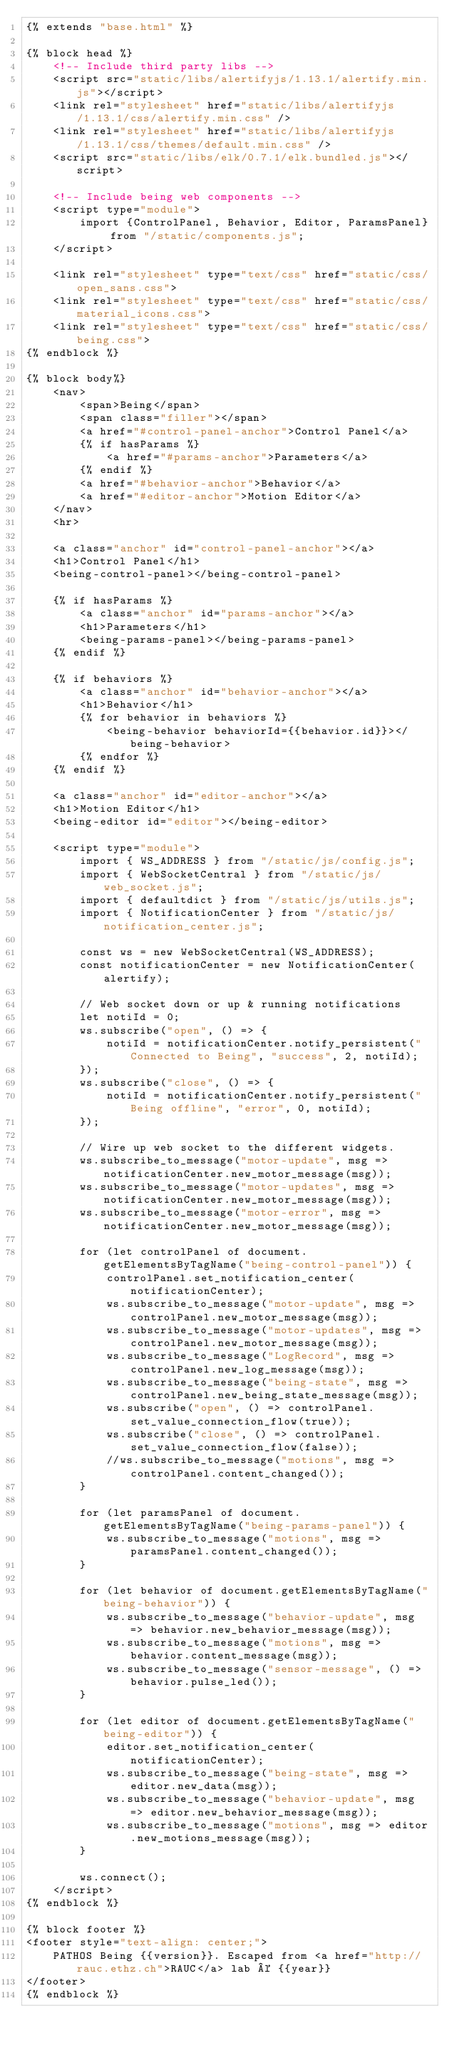Convert code to text. <code><loc_0><loc_0><loc_500><loc_500><_HTML_>{% extends "base.html" %}

{% block head %}
    <!-- Include third party libs -->
    <script src="static/libs/alertifyjs/1.13.1/alertify.min.js"></script>
    <link rel="stylesheet" href="static/libs/alertifyjs/1.13.1/css/alertify.min.css" />
    <link rel="stylesheet" href="static/libs/alertifyjs/1.13.1/css/themes/default.min.css" />
    <script src="static/libs/elk/0.7.1/elk.bundled.js"></script>

    <!-- Include being web components -->
    <script type="module">
        import {ControlPanel, Behavior, Editor, ParamsPanel} from "/static/components.js";
    </script>

    <link rel="stylesheet" type="text/css" href="static/css/open_sans.css">
    <link rel="stylesheet" type="text/css" href="static/css/material_icons.css">
    <link rel="stylesheet" type="text/css" href="static/css/being.css">
{% endblock %}

{% block body%}
    <nav>
        <span>Being</span>
        <span class="filler"></span>
        <a href="#control-panel-anchor">Control Panel</a>
        {% if hasParams %}
            <a href="#params-anchor">Parameters</a>
        {% endif %}
        <a href="#behavior-anchor">Behavior</a>
        <a href="#editor-anchor">Motion Editor</a>
    </nav>
    <hr>

    <a class="anchor" id="control-panel-anchor"></a>
    <h1>Control Panel</h1>
    <being-control-panel></being-control-panel>

    {% if hasParams %}
        <a class="anchor" id="params-anchor"></a>
        <h1>Parameters</h1>
        <being-params-panel></being-params-panel>
    {% endif %}

    {% if behaviors %}
        <a class="anchor" id="behavior-anchor"></a>
        <h1>Behavior</h1>
        {% for behavior in behaviors %}
            <being-behavior behaviorId={{behavior.id}}></being-behavior>
        {% endfor %}
    {% endif %}

    <a class="anchor" id="editor-anchor"></a>
    <h1>Motion Editor</h1>
    <being-editor id="editor"></being-editor>

    <script type="module">
        import { WS_ADDRESS } from "/static/js/config.js";
        import { WebSocketCentral } from "/static/js/web_socket.js";
        import { defaultdict } from "/static/js/utils.js";
        import { NotificationCenter } from "/static/js/notification_center.js";

        const ws = new WebSocketCentral(WS_ADDRESS);
        const notificationCenter = new NotificationCenter(alertify);

        // Web socket down or up & running notifications
        let notiId = 0;
        ws.subscribe("open", () => {
            notiId = notificationCenter.notify_persistent("Connected to Being", "success", 2, notiId);
        });
        ws.subscribe("close", () => {
            notiId = notificationCenter.notify_persistent("Being offline", "error", 0, notiId);
        });

        // Wire up web socket to the different widgets.
        ws.subscribe_to_message("motor-update", msg => notificationCenter.new_motor_message(msg));
        ws.subscribe_to_message("motor-updates", msg => notificationCenter.new_motor_message(msg));
        ws.subscribe_to_message("motor-error", msg => notificationCenter.new_motor_message(msg));

        for (let controlPanel of document.getElementsByTagName("being-control-panel")) {
            controlPanel.set_notification_center(notificationCenter);
            ws.subscribe_to_message("motor-update", msg => controlPanel.new_motor_message(msg));
            ws.subscribe_to_message("motor-updates", msg => controlPanel.new_motor_message(msg));
            ws.subscribe_to_message("LogRecord", msg => controlPanel.new_log_message(msg));
            ws.subscribe_to_message("being-state", msg => controlPanel.new_being_state_message(msg));
            ws.subscribe("open", () => controlPanel.set_value_connection_flow(true));
            ws.subscribe("close", () => controlPanel.set_value_connection_flow(false));
            //ws.subscribe_to_message("motions", msg => controlPanel.content_changed());
        }

        for (let paramsPanel of document.getElementsByTagName("being-params-panel")) {
            ws.subscribe_to_message("motions", msg => paramsPanel.content_changed());
        }

        for (let behavior of document.getElementsByTagName("being-behavior")) {
            ws.subscribe_to_message("behavior-update", msg => behavior.new_behavior_message(msg));
            ws.subscribe_to_message("motions", msg => behavior.content_message(msg));
            ws.subscribe_to_message("sensor-message", () => behavior.pulse_led());
        }

        for (let editor of document.getElementsByTagName("being-editor")) {
            editor.set_notification_center(notificationCenter);
            ws.subscribe_to_message("being-state", msg => editor.new_data(msg));
            ws.subscribe_to_message("behavior-update", msg => editor.new_behavior_message(msg));
            ws.subscribe_to_message("motions", msg => editor.new_motions_message(msg));
        }

        ws.connect();
    </script>
{% endblock %}

{% block footer %}
<footer style="text-align: center;">
    PATHOS Being {{version}}. Escaped from <a href="http://rauc.ethz.ch">RAUC</a> lab © {{year}}
</footer>
{% endblock %}
</code> 